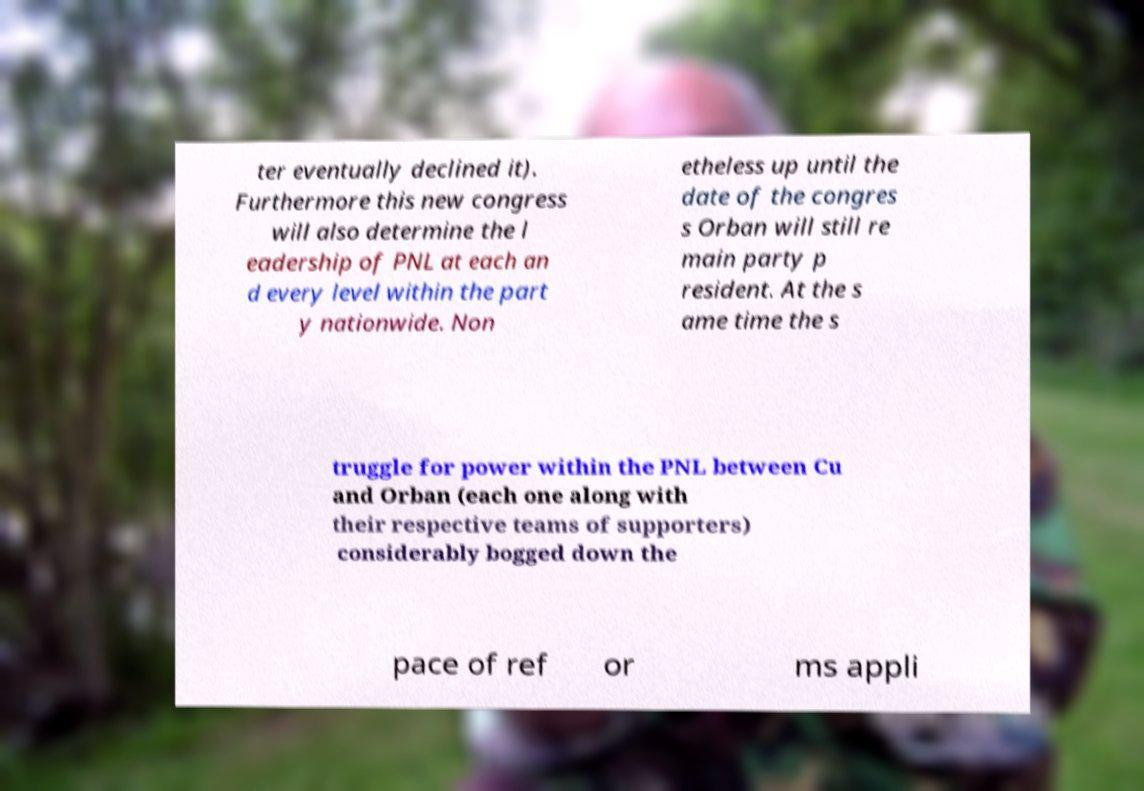Could you assist in decoding the text presented in this image and type it out clearly? ter eventually declined it). Furthermore this new congress will also determine the l eadership of PNL at each an d every level within the part y nationwide. Non etheless up until the date of the congres s Orban will still re main party p resident. At the s ame time the s truggle for power within the PNL between Cu and Orban (each one along with their respective teams of supporters) considerably bogged down the pace of ref or ms appli 